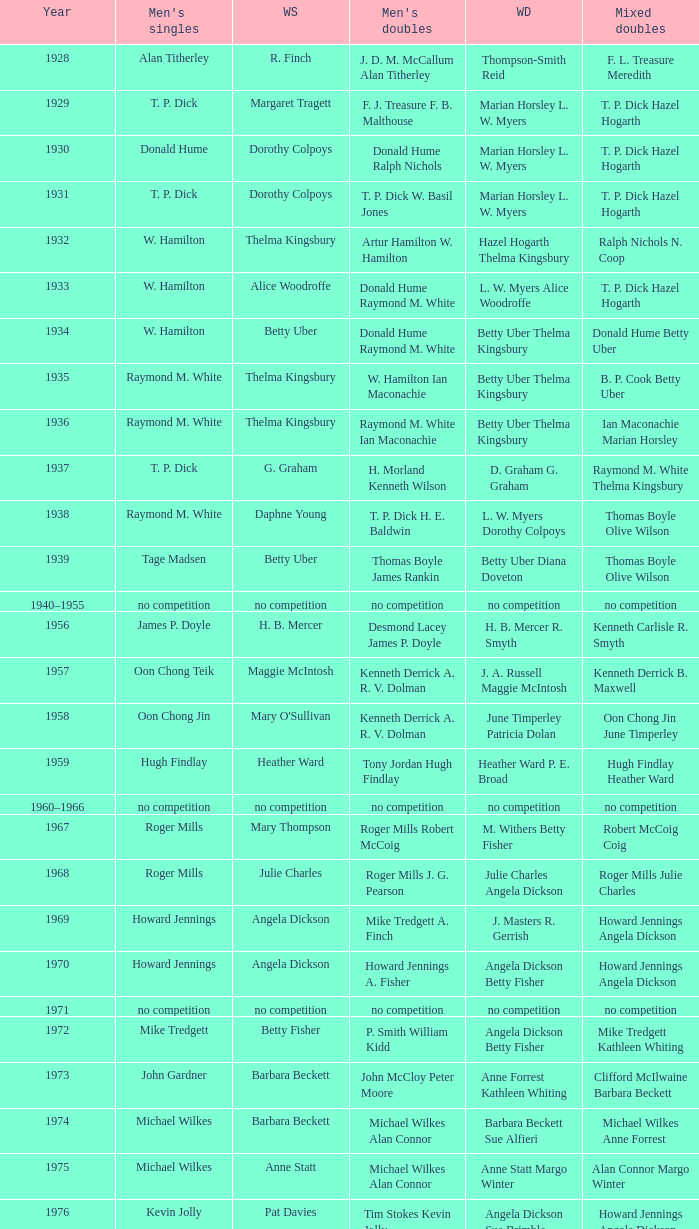Who won the Women's doubles in the year that Billy Gilliland Karen Puttick won the Mixed doubles? Jane Webster Karen Puttick. 